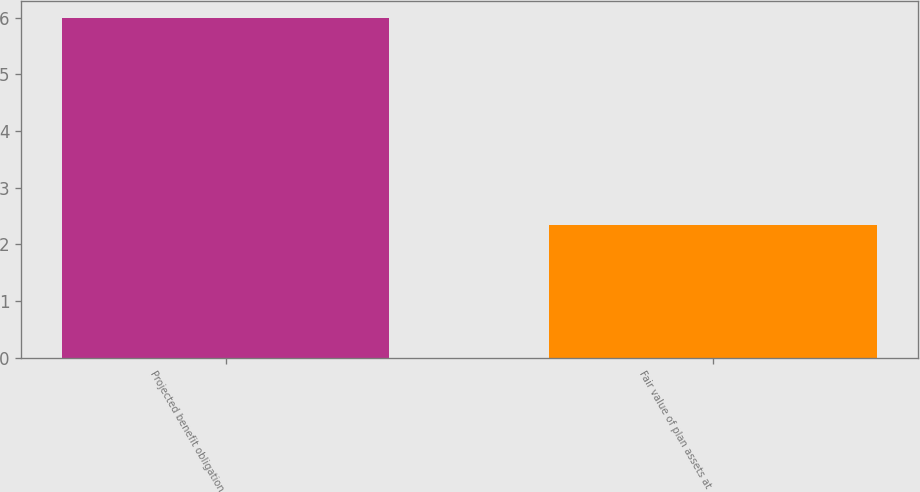<chart> <loc_0><loc_0><loc_500><loc_500><bar_chart><fcel>Projected benefit obligation<fcel>Fair value of plan assets at<nl><fcel>6<fcel>2.35<nl></chart> 